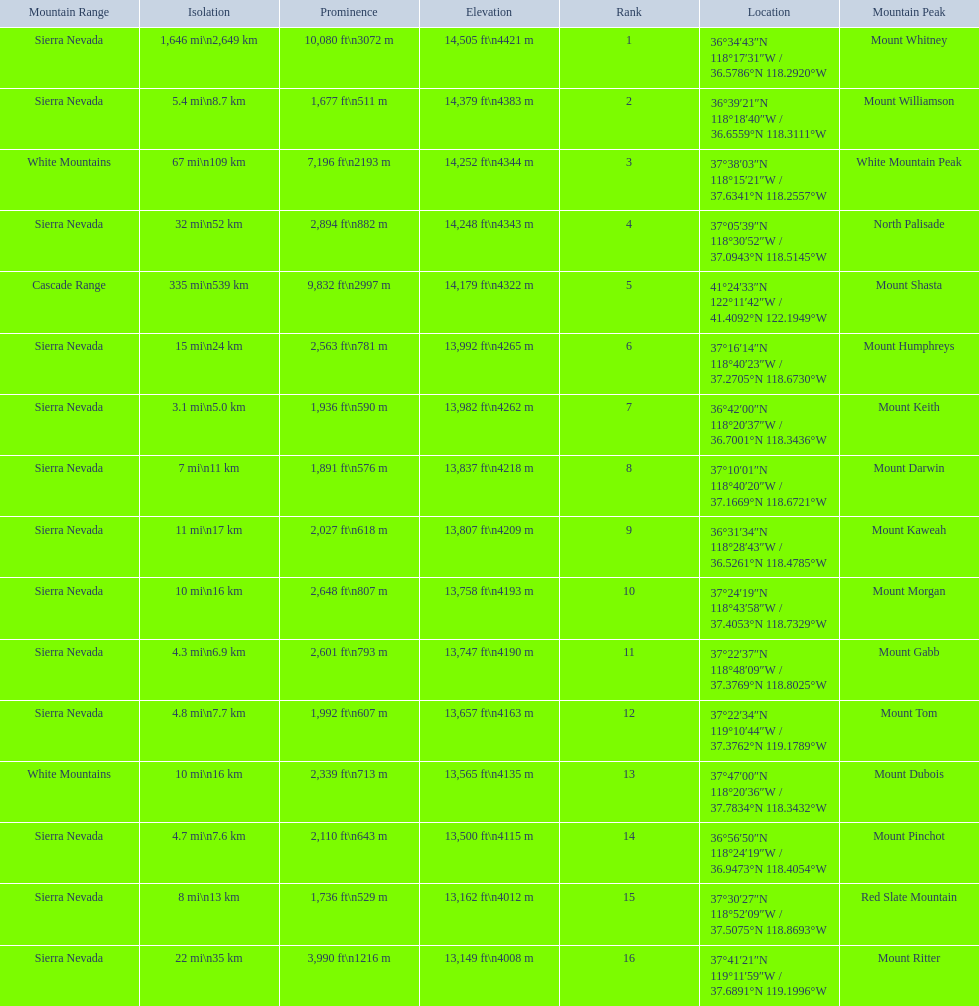What mountain peak is listed for the sierra nevada mountain range? Mount Whitney. What mountain peak has an elevation of 14,379ft? Mount Williamson. Which mountain is listed for the cascade range? Mount Shasta. 